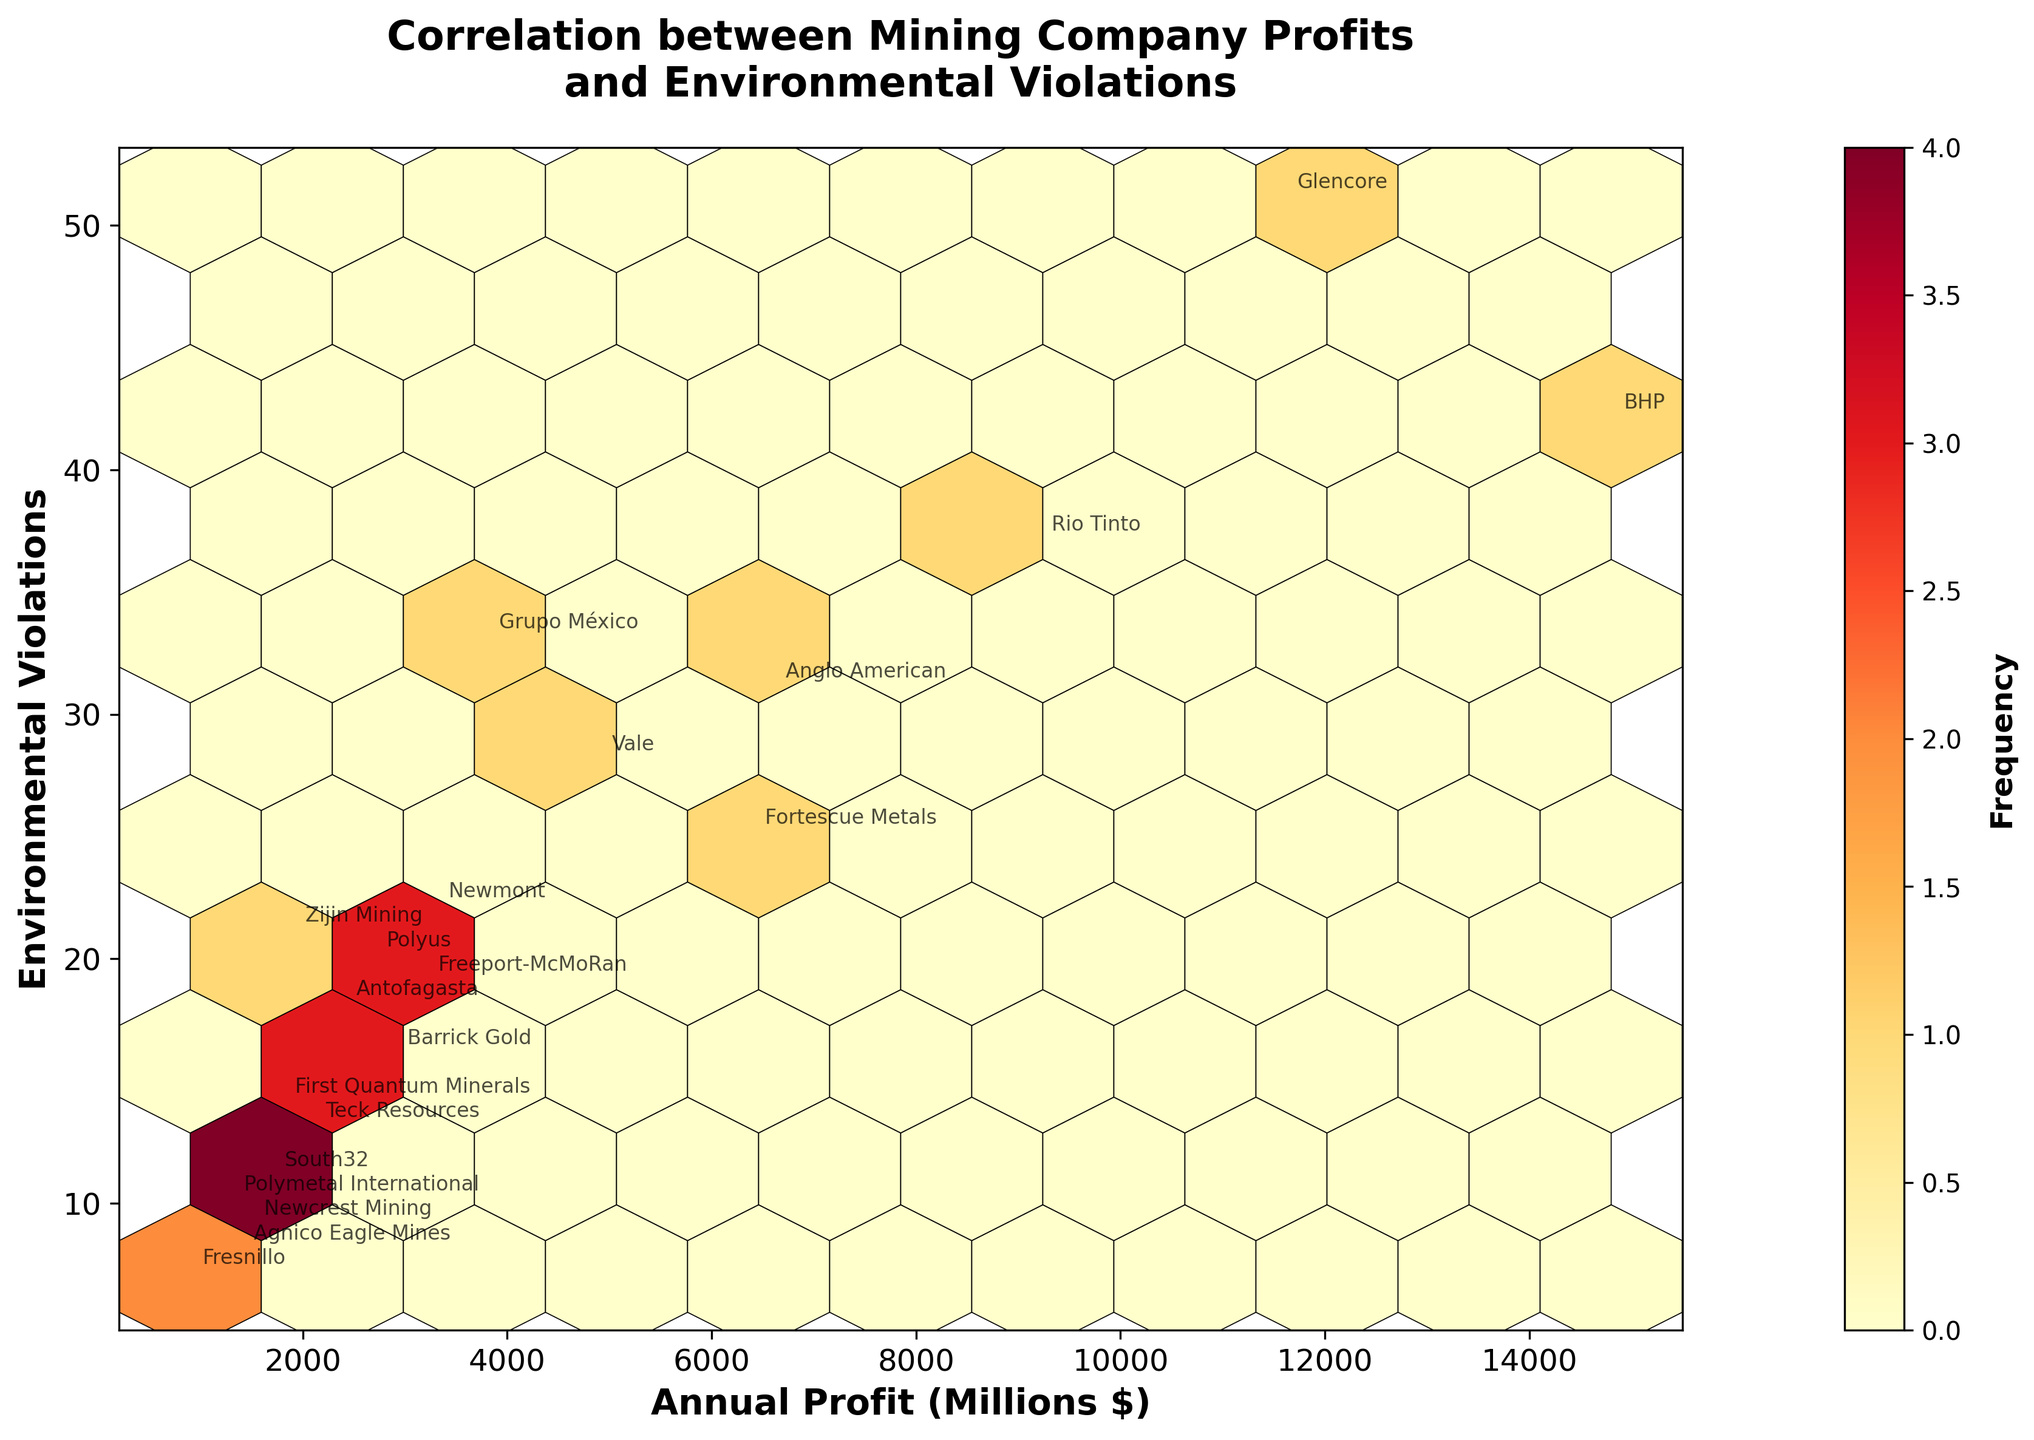What is the title of the figure? The title of the figure is usually the text at the top of the plot. In this case, it reads "Correlation between Mining Company Profits and Environmental Violations."
Answer: Correlation between Mining Company Profits and Environmental Violations What do the X and Y axes represent? The X and Y axes generally indicate the variables being plotted. Here, the X axis is labeled "Annual Profit (Millions $)" representing the annual profits of the mining companies in millions of dollars, and the Y axis is labeled "Environmental Violations" showing the number of environmental violations.
Answer: X axis: Annual Profit (Millions $), Y axis: Environmental Violations How many companies have annual profits above $10,000 million? To find the number of companies with annual profits above $10,000 million, we can look at the X axis and count the data points (annotated with company names) that are positioned beyond this value. There are two companies: BHP and Glencore.
Answer: 2 Which company has the highest number of environmental violations and what is the corresponding profit? The highest number of environmental violations can be identified by looking at the topmost data point on the Y axis. This is 51 violations, corresponding to the company Glencore, which has an annual profit of $11,600 million according to the annotations.
Answer: Glencore, $11,600 million Are there more companies with profits below or above $5,000 million? By dividing the X axis at the $5,000 million mark, we can count the number of data points (company names) on each side. Below $5,000 million, there are 12 companies and above $5,000 million, there are 8 companies.
Answer: Below $5,000 million What is the relation between the frequency indicated by the color and the density of points on the hexbin plot? The color intensity on the hexbin plot indicates frequency. Darker colors represent higher frequencies, meaning more data points are clustered in these areas. So, the higher the density of points, the darker or more intense the color of the hexagonal bins.
Answer: Darker colors indicate higher frequency Which two companies have the closest number of environmental violations and what are their profit differences? By looking at the data points closely, we see that Freeport-McMoRan and Newmont have 19 and 22 violations, respectively. The difference in their annual profits is $1,000 million for Newmont and $3,200 million for Freeport-McMoRan, resulting in a $1,000 million difference.
Answer: Freeport-McMoRan and Newmont, $1,000 million Which company with the highest profit has the least environmental violations? To find this, locate the data point with the highest X value on the plot. BHP, with the highest profit of $14,800 million and having 42 violations, is the company with the least environmental violations among those with the highest profit.
Answer: BHP Is there a clear correlation trend that can be observed from the hexbin plot between profits and environmental violations? To determine if there is a correlation, observe the general scatter and trend of the hex bins. There is no clear upward or downward trend, suggesting that there is no obvious direct correlation between mining company profits and the number of environmental violations from the given data.
Answer: No clear correlation 